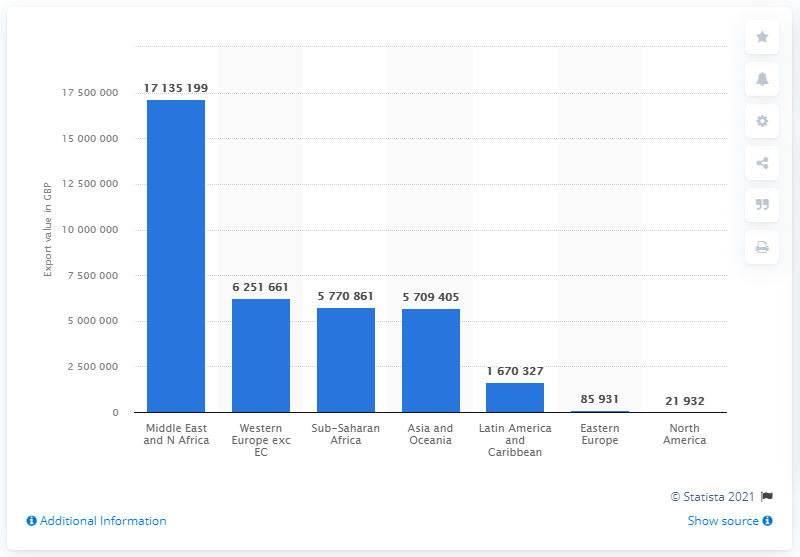Mention a couple of crucial points in this snapshot. In 2018, the UK exported 171,351,999 pounds of sugar to the Middle East and North Africa, representing a significant amount of British pounds worth of sugar. 